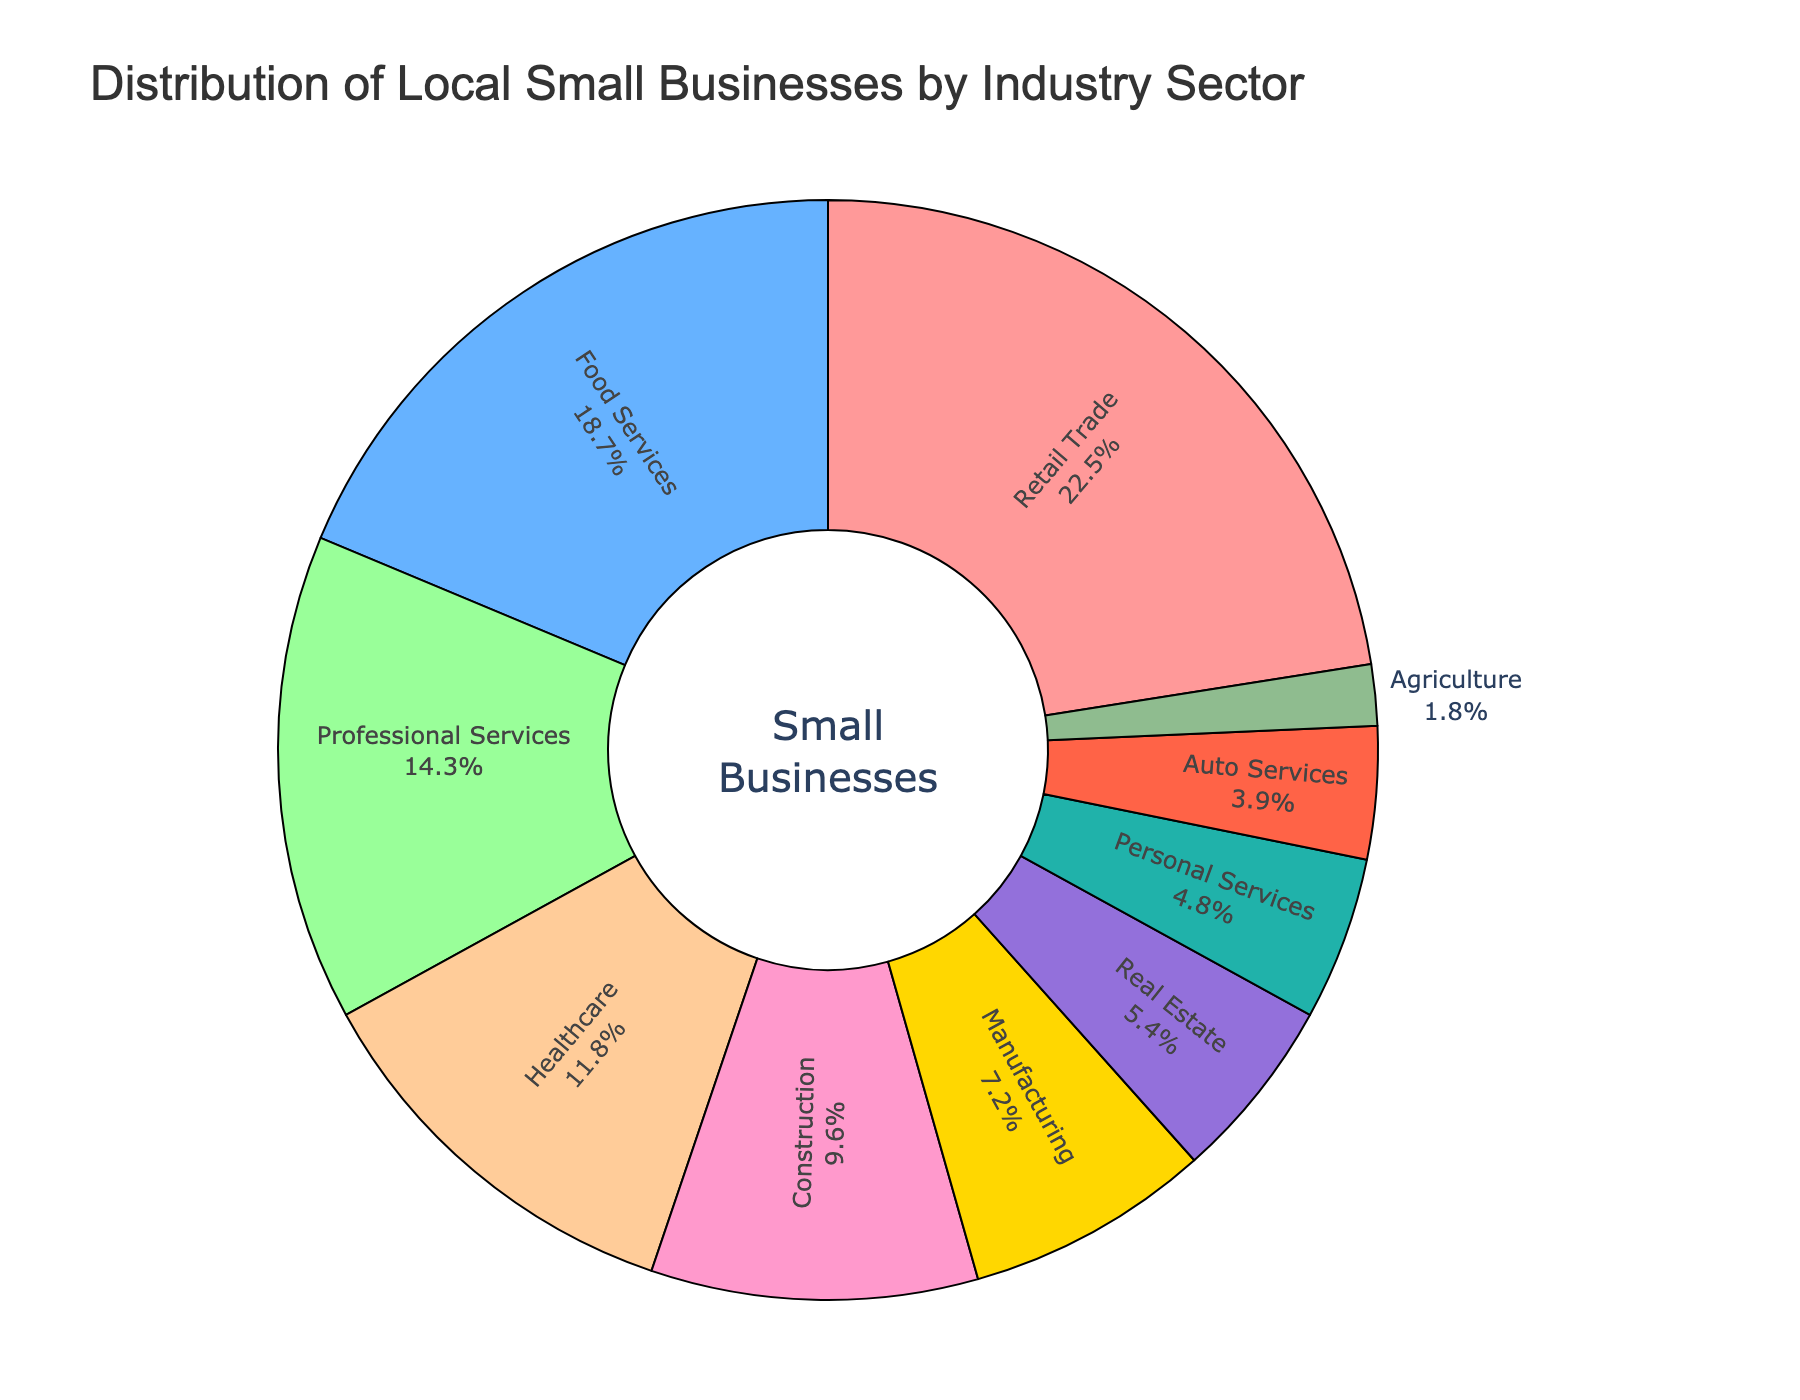Which industry sector has the largest percentage of local small businesses? The largest segment in the pie chart is Retail Trade, which takes up the most space.
Answer: Retail Trade Which two industry sectors combined account for the highest percentage of small businesses? The two largest segments are Retail Trade (22.5%) and Food Services (18.7%). Adding these together yields 22.5 + 18.7 = 41.2%.
Answer: Retail Trade and Food Services How much more significant is the percentage of businesses in the Professional Services sector compared to the Auto Services sector? The pie chart shows that Professional Services is 14.3% while Auto Services is 3.9%. Subtract 3.9 from 14.3 to get 14.3 - 3.9 = 10.4%.
Answer: 10.4% What’s the approximate average percentage of small businesses in the Construction, Real Estate, and Agriculture sectors? The sectors have percentages of 9.6%, 5.4%, and 1.8% respectively. Adding them up gives 9.6 + 5.4 + 1.8 = 16.8%, and dividing by 3 gives 16.8 / 3 = 5.6%.
Answer: 5.6% Which sector has a smaller percentage, Manufacturing or Personal Services? Comparing the two segments, Manufacturing stands at 7.2% while Personal Services stands at 4.8%. Hence, Personal Services is smaller.
Answer: Personal Services What is the total percentage of small businesses in sectors related to services (including Food Services, Professional Services, Personal Services, and Auto Services)? The sectors have percentages of 18.7%, 14.3%, 4.8%, and 3.9% respectively. Summing these values gives 18.7 + 14.3 + 4.8 + 3.9 = 41.7%.
Answer: 41.7% What is the difference in percentage between Healthcare and the combined percentage of Agriculture and Auto Services? Healthcare stands at 11.8%, while Agriculture and Auto Services are 1.8% and 3.9%, respectively. Adding the latter two gives 1.8 + 3.9 = 5.7%. Subtract this from Healthcare gives 11.8 - 5.7 = 6.1%.
Answer: 6.1% Which segment has a greenish color, and what percentage of small businesses does it represent? The segments given more detailed observations show that the Personal Services segment is colored greenish and it represents 4.8%.
Answer: Personal Services, 4.8% Is the percentage of small businesses in Real Estate greater than half the percentage in the Healthcare sector? Healthcare stands at 11.8%, and half of this value is 11.8 / 2 = 5.9%. Real Estate is at 5.4%, which is less than 5.9%.
Answer: No 